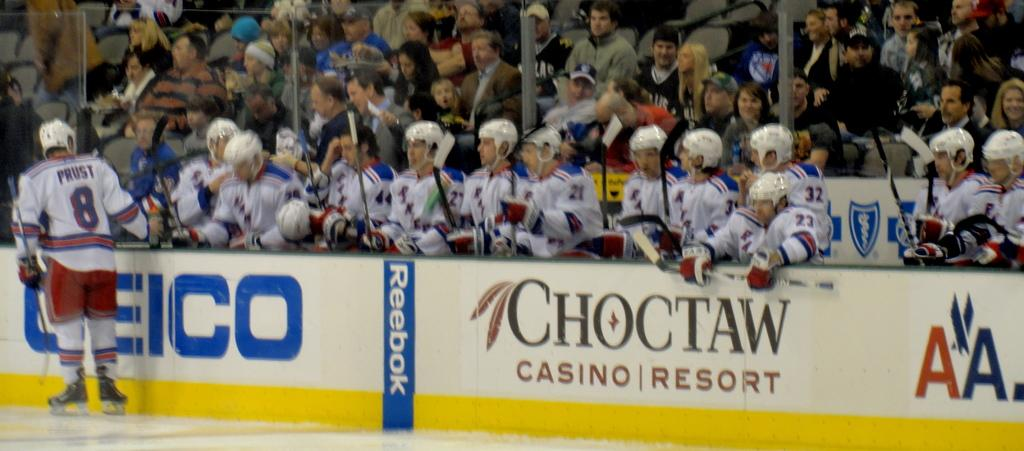Provide a one-sentence caption for the provided image. A hockey ring with an advertisement for Geico. 